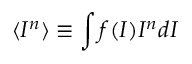<formula> <loc_0><loc_0><loc_500><loc_500>\langle I ^ { n } \rangle \equiv \int f ( I ) I ^ { n } d I</formula> 